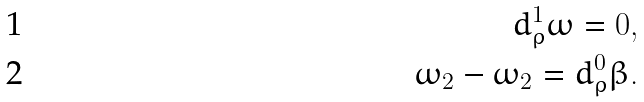Convert formula to latex. <formula><loc_0><loc_0><loc_500><loc_500>d _ { \rho } ^ { 1 } \omega = 0 , \\ \omega _ { 2 } - \omega _ { 2 } = d _ { \rho } ^ { 0 } \beta .</formula> 